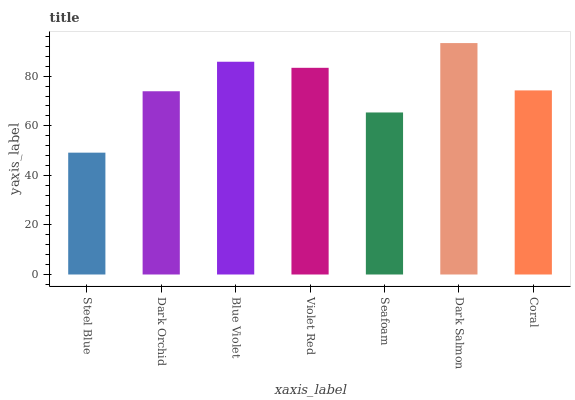Is Steel Blue the minimum?
Answer yes or no. Yes. Is Dark Salmon the maximum?
Answer yes or no. Yes. Is Dark Orchid the minimum?
Answer yes or no. No. Is Dark Orchid the maximum?
Answer yes or no. No. Is Dark Orchid greater than Steel Blue?
Answer yes or no. Yes. Is Steel Blue less than Dark Orchid?
Answer yes or no. Yes. Is Steel Blue greater than Dark Orchid?
Answer yes or no. No. Is Dark Orchid less than Steel Blue?
Answer yes or no. No. Is Coral the high median?
Answer yes or no. Yes. Is Coral the low median?
Answer yes or no. Yes. Is Blue Violet the high median?
Answer yes or no. No. Is Dark Salmon the low median?
Answer yes or no. No. 